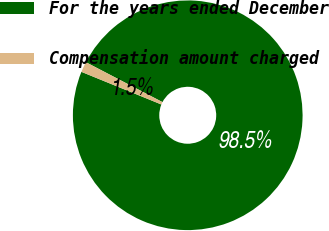Convert chart. <chart><loc_0><loc_0><loc_500><loc_500><pie_chart><fcel>For the years ended December<fcel>Compensation amount charged<nl><fcel>98.53%<fcel>1.47%<nl></chart> 